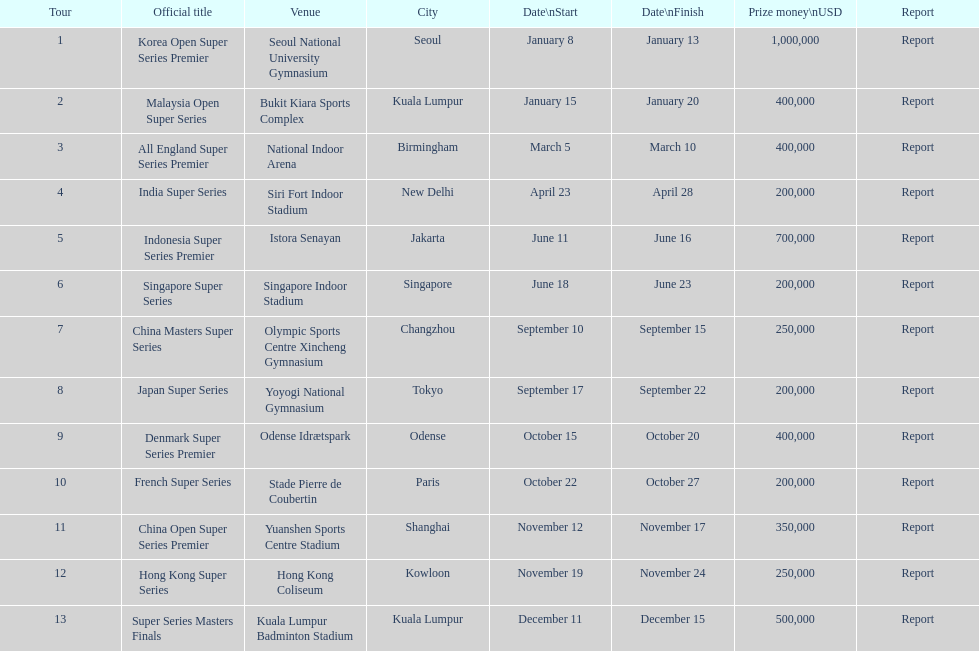Can you parse all the data within this table? {'header': ['Tour', 'Official title', 'Venue', 'City', 'Date\\nStart', 'Date\\nFinish', 'Prize money\\nUSD', 'Report'], 'rows': [['1', 'Korea Open Super Series Premier', 'Seoul National University Gymnasium', 'Seoul', 'January 8', 'January 13', '1,000,000', 'Report'], ['2', 'Malaysia Open Super Series', 'Bukit Kiara Sports Complex', 'Kuala Lumpur', 'January 15', 'January 20', '400,000', 'Report'], ['3', 'All England Super Series Premier', 'National Indoor Arena', 'Birmingham', 'March 5', 'March 10', '400,000', 'Report'], ['4', 'India Super Series', 'Siri Fort Indoor Stadium', 'New Delhi', 'April 23', 'April 28', '200,000', 'Report'], ['5', 'Indonesia Super Series Premier', 'Istora Senayan', 'Jakarta', 'June 11', 'June 16', '700,000', 'Report'], ['6', 'Singapore Super Series', 'Singapore Indoor Stadium', 'Singapore', 'June 18', 'June 23', '200,000', 'Report'], ['7', 'China Masters Super Series', 'Olympic Sports Centre Xincheng Gymnasium', 'Changzhou', 'September 10', 'September 15', '250,000', 'Report'], ['8', 'Japan Super Series', 'Yoyogi National Gymnasium', 'Tokyo', 'September 17', 'September 22', '200,000', 'Report'], ['9', 'Denmark Super Series Premier', 'Odense Idrætspark', 'Odense', 'October 15', 'October 20', '400,000', 'Report'], ['10', 'French Super Series', 'Stade Pierre de Coubertin', 'Paris', 'October 22', 'October 27', '200,000', 'Report'], ['11', 'China Open Super Series Premier', 'Yuanshen Sports Centre Stadium', 'Shanghai', 'November 12', 'November 17', '350,000', 'Report'], ['12', 'Hong Kong Super Series', 'Hong Kong Coliseum', 'Kowloon', 'November 19', 'November 24', '250,000', 'Report'], ['13', 'Super Series Masters Finals', 'Kuala Lumpur Badminton Stadium', 'Kuala Lumpur', 'December 11', 'December 15', '500,000', 'Report']]} Which has the same prize money as the french super series? Japan Super Series, Singapore Super Series, India Super Series. 